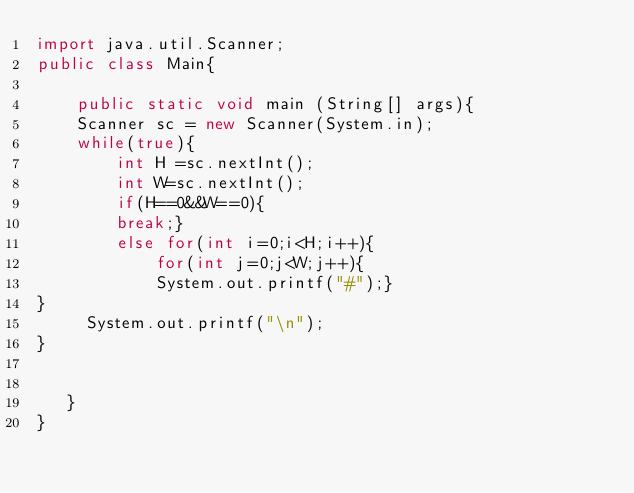<code> <loc_0><loc_0><loc_500><loc_500><_Java_>import java.util.Scanner;
public class Main{ 

    public static void main (String[] args){
	Scanner sc = new Scanner(System.in);
	while(true){
	    int H =sc.nextInt();
	    int W=sc.nextInt();
	    if(H==0&&W==0){
		break;}
	    else for(int i=0;i<H;i++){
		    for(int j=0;j<W;j++){
			System.out.printf("#");}
}
	 System.out.printf("\n");
}
	    
	    	
   }
}</code> 